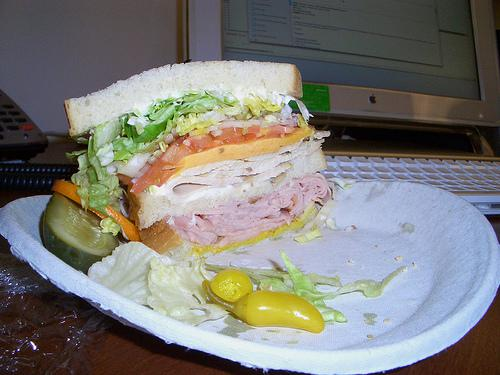Question: what is red?
Choices:
A. Cups.
B. Tomatoes.
C. Radishes.
D. Balls.
Answer with the letter. Answer: B Question: what is green laying on the plate?
Choices:
A. Lettuce.
B. Lime.
C. Cabbage.
D. Pickle.
Answer with the letter. Answer: D Question: why would the lettuce be on the plate?
Choices:
A. Salad.
B. Side dish.
C. Fell off.
D. For burger.
Answer with the letter. Answer: C Question: how is the sandwich cut?
Choices:
A. In half.
B. Diagonally.
C. Down the middle.
D. Vertically.
Answer with the letter. Answer: A 